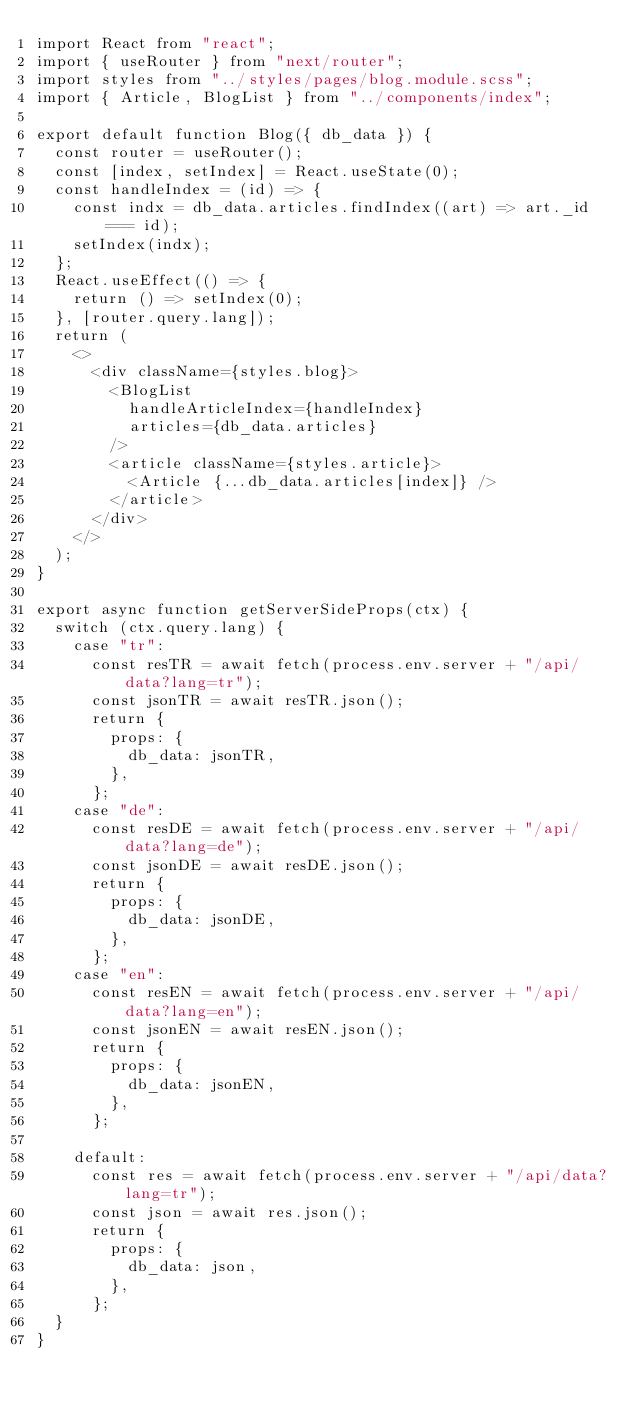Convert code to text. <code><loc_0><loc_0><loc_500><loc_500><_JavaScript_>import React from "react";
import { useRouter } from "next/router";
import styles from "../styles/pages/blog.module.scss";
import { Article, BlogList } from "../components/index";

export default function Blog({ db_data }) {
  const router = useRouter();
  const [index, setIndex] = React.useState(0);
  const handleIndex = (id) => {
    const indx = db_data.articles.findIndex((art) => art._id === id);
    setIndex(indx);
  };
  React.useEffect(() => {
    return () => setIndex(0);
  }, [router.query.lang]);
  return (
    <>
      <div className={styles.blog}>
        <BlogList
          handleArticleIndex={handleIndex}
          articles={db_data.articles}
        />
        <article className={styles.article}>
          <Article {...db_data.articles[index]} />
        </article>
      </div>
    </>
  );
}

export async function getServerSideProps(ctx) {
  switch (ctx.query.lang) {
    case "tr":
      const resTR = await fetch(process.env.server + "/api/data?lang=tr");
      const jsonTR = await resTR.json();
      return {
        props: {
          db_data: jsonTR,
        },
      };
    case "de":
      const resDE = await fetch(process.env.server + "/api/data?lang=de");
      const jsonDE = await resDE.json();
      return {
        props: {
          db_data: jsonDE,
        },
      };
    case "en":
      const resEN = await fetch(process.env.server + "/api/data?lang=en");
      const jsonEN = await resEN.json();
      return {
        props: {
          db_data: jsonEN,
        },
      };

    default:
      const res = await fetch(process.env.server + "/api/data?lang=tr");
      const json = await res.json();
      return {
        props: {
          db_data: json,
        },
      };
  }
}
</code> 